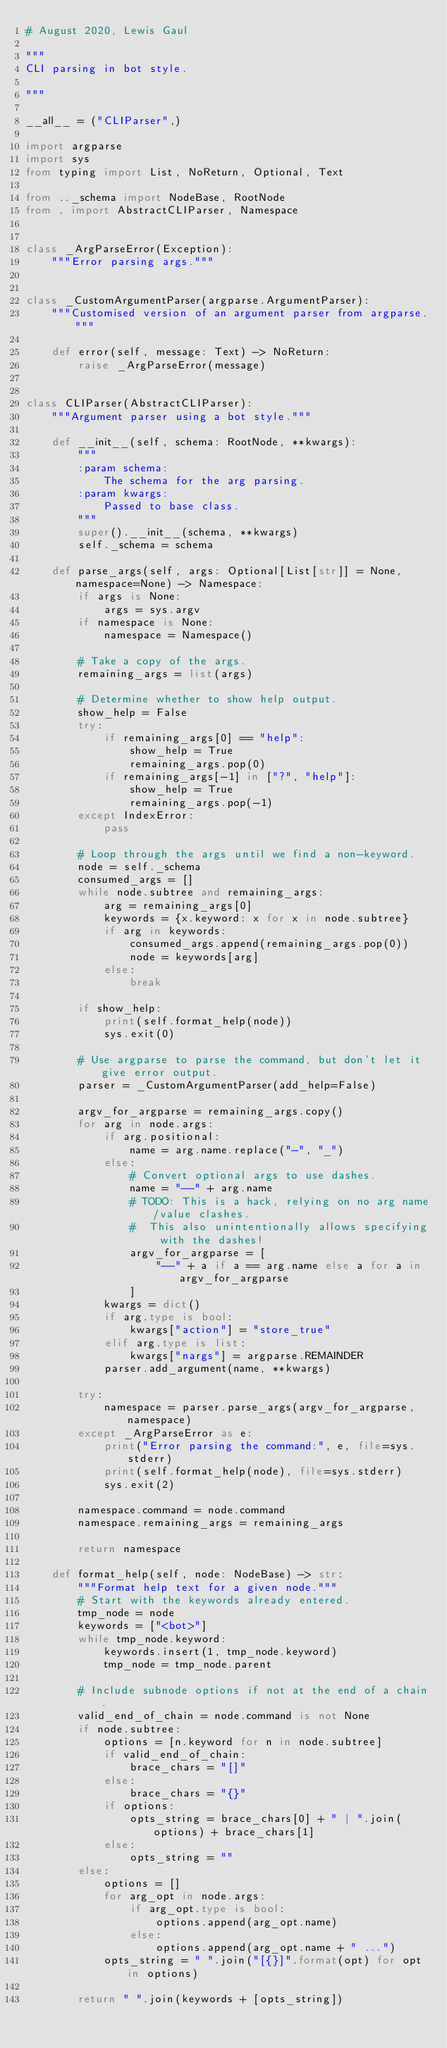Convert code to text. <code><loc_0><loc_0><loc_500><loc_500><_Python_># August 2020, Lewis Gaul

"""
CLI parsing in bot style.

"""

__all__ = ("CLIParser",)

import argparse
import sys
from typing import List, NoReturn, Optional, Text

from .._schema import NodeBase, RootNode
from . import AbstractCLIParser, Namespace


class _ArgParseError(Exception):
    """Error parsing args."""


class _CustomArgumentParser(argparse.ArgumentParser):
    """Customised version of an argument parser from argparse."""

    def error(self, message: Text) -> NoReturn:
        raise _ArgParseError(message)


class CLIParser(AbstractCLIParser):
    """Argument parser using a bot style."""

    def __init__(self, schema: RootNode, **kwargs):
        """
        :param schema:
            The schema for the arg parsing.
        :param kwargs:
            Passed to base class.
        """
        super().__init__(schema, **kwargs)
        self._schema = schema

    def parse_args(self, args: Optional[List[str]] = None, namespace=None) -> Namespace:
        if args is None:
            args = sys.argv
        if namespace is None:
            namespace = Namespace()

        # Take a copy of the args.
        remaining_args = list(args)

        # Determine whether to show help output.
        show_help = False
        try:
            if remaining_args[0] == "help":
                show_help = True
                remaining_args.pop(0)
            if remaining_args[-1] in ["?", "help"]:
                show_help = True
                remaining_args.pop(-1)
        except IndexError:
            pass

        # Loop through the args until we find a non-keyword.
        node = self._schema
        consumed_args = []
        while node.subtree and remaining_args:
            arg = remaining_args[0]
            keywords = {x.keyword: x for x in node.subtree}
            if arg in keywords:
                consumed_args.append(remaining_args.pop(0))
                node = keywords[arg]
            else:
                break

        if show_help:
            print(self.format_help(node))
            sys.exit(0)

        # Use argparse to parse the command, but don't let it give error output.
        parser = _CustomArgumentParser(add_help=False)

        argv_for_argparse = remaining_args.copy()
        for arg in node.args:
            if arg.positional:
                name = arg.name.replace("-", "_")
            else:
                # Convert optional args to use dashes.
                name = "--" + arg.name
                # TODO: This is a hack, relying on no arg name/value clashes.
                #  This also unintentionally allows specifying with the dashes!
                argv_for_argparse = [
                    "--" + a if a == arg.name else a for a in argv_for_argparse
                ]
            kwargs = dict()
            if arg.type is bool:
                kwargs["action"] = "store_true"
            elif arg.type is list:
                kwargs["nargs"] = argparse.REMAINDER
            parser.add_argument(name, **kwargs)

        try:
            namespace = parser.parse_args(argv_for_argparse, namespace)
        except _ArgParseError as e:
            print("Error parsing the command:", e, file=sys.stderr)
            print(self.format_help(node), file=sys.stderr)
            sys.exit(2)

        namespace.command = node.command
        namespace.remaining_args = remaining_args

        return namespace

    def format_help(self, node: NodeBase) -> str:
        """Format help text for a given node."""
        # Start with the keywords already entered.
        tmp_node = node
        keywords = ["<bot>"]
        while tmp_node.keyword:
            keywords.insert(1, tmp_node.keyword)
            tmp_node = tmp_node.parent

        # Include subnode options if not at the end of a chain.
        valid_end_of_chain = node.command is not None
        if node.subtree:
            options = [n.keyword for n in node.subtree]
            if valid_end_of_chain:
                brace_chars = "[]"
            else:
                brace_chars = "{}"
            if options:
                opts_string = brace_chars[0] + " | ".join(options) + brace_chars[1]
            else:
                opts_string = ""
        else:
            options = []
            for arg_opt in node.args:
                if arg_opt.type is bool:
                    options.append(arg_opt.name)
                else:
                    options.append(arg_opt.name + " ...")
            opts_string = " ".join("[{}]".format(opt) for opt in options)

        return " ".join(keywords + [opts_string])
</code> 